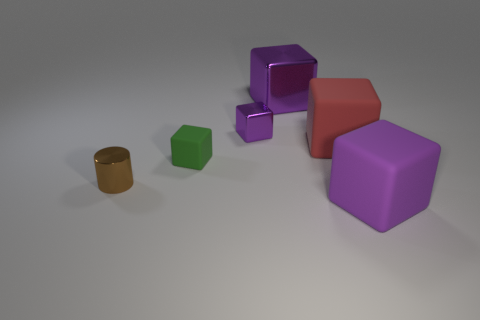Subtract all brown cylinders. How many purple blocks are left? 3 Subtract 1 blocks. How many blocks are left? 4 Subtract all red rubber cubes. How many cubes are left? 4 Subtract all red cubes. How many cubes are left? 4 Subtract all red blocks. Subtract all red balls. How many blocks are left? 4 Add 3 purple metallic things. How many objects exist? 9 Subtract all cylinders. How many objects are left? 5 Subtract 1 brown cylinders. How many objects are left? 5 Subtract all small shiny cubes. Subtract all large yellow shiny things. How many objects are left? 5 Add 1 tiny brown metallic objects. How many tiny brown metallic objects are left? 2 